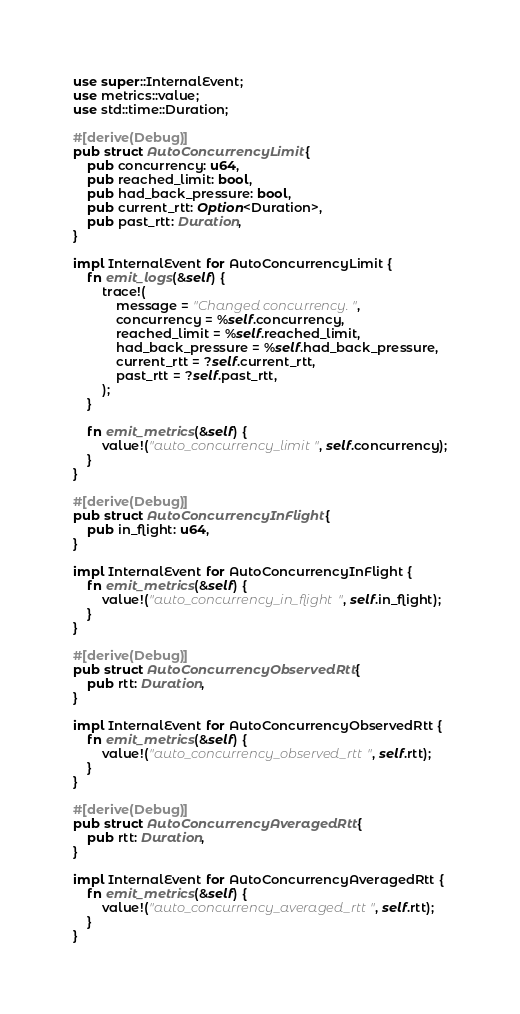<code> <loc_0><loc_0><loc_500><loc_500><_Rust_>use super::InternalEvent;
use metrics::value;
use std::time::Duration;

#[derive(Debug)]
pub struct AutoConcurrencyLimit {
    pub concurrency: u64,
    pub reached_limit: bool,
    pub had_back_pressure: bool,
    pub current_rtt: Option<Duration>,
    pub past_rtt: Duration,
}

impl InternalEvent for AutoConcurrencyLimit {
    fn emit_logs(&self) {
        trace!(
            message = "Changed concurrency.",
            concurrency = %self.concurrency,
            reached_limit = %self.reached_limit,
            had_back_pressure = %self.had_back_pressure,
            current_rtt = ?self.current_rtt,
            past_rtt = ?self.past_rtt,
        );
    }

    fn emit_metrics(&self) {
        value!("auto_concurrency_limit", self.concurrency);
    }
}

#[derive(Debug)]
pub struct AutoConcurrencyInFlight {
    pub in_flight: u64,
}

impl InternalEvent for AutoConcurrencyInFlight {
    fn emit_metrics(&self) {
        value!("auto_concurrency_in_flight", self.in_flight);
    }
}

#[derive(Debug)]
pub struct AutoConcurrencyObservedRtt {
    pub rtt: Duration,
}

impl InternalEvent for AutoConcurrencyObservedRtt {
    fn emit_metrics(&self) {
        value!("auto_concurrency_observed_rtt", self.rtt);
    }
}

#[derive(Debug)]
pub struct AutoConcurrencyAveragedRtt {
    pub rtt: Duration,
}

impl InternalEvent for AutoConcurrencyAveragedRtt {
    fn emit_metrics(&self) {
        value!("auto_concurrency_averaged_rtt", self.rtt);
    }
}
</code> 